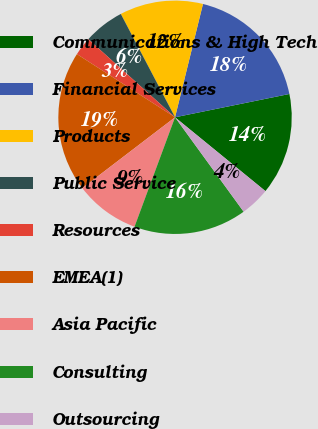Convert chart. <chart><loc_0><loc_0><loc_500><loc_500><pie_chart><fcel>Communications & High Tech<fcel>Financial Services<fcel>Products<fcel>Public Service<fcel>Resources<fcel>EMEA(1)<fcel>Asia Pacific<fcel>Consulting<fcel>Outsourcing<nl><fcel>14.1%<fcel>17.95%<fcel>11.54%<fcel>5.64%<fcel>2.56%<fcel>19.49%<fcel>8.97%<fcel>15.64%<fcel>4.1%<nl></chart> 